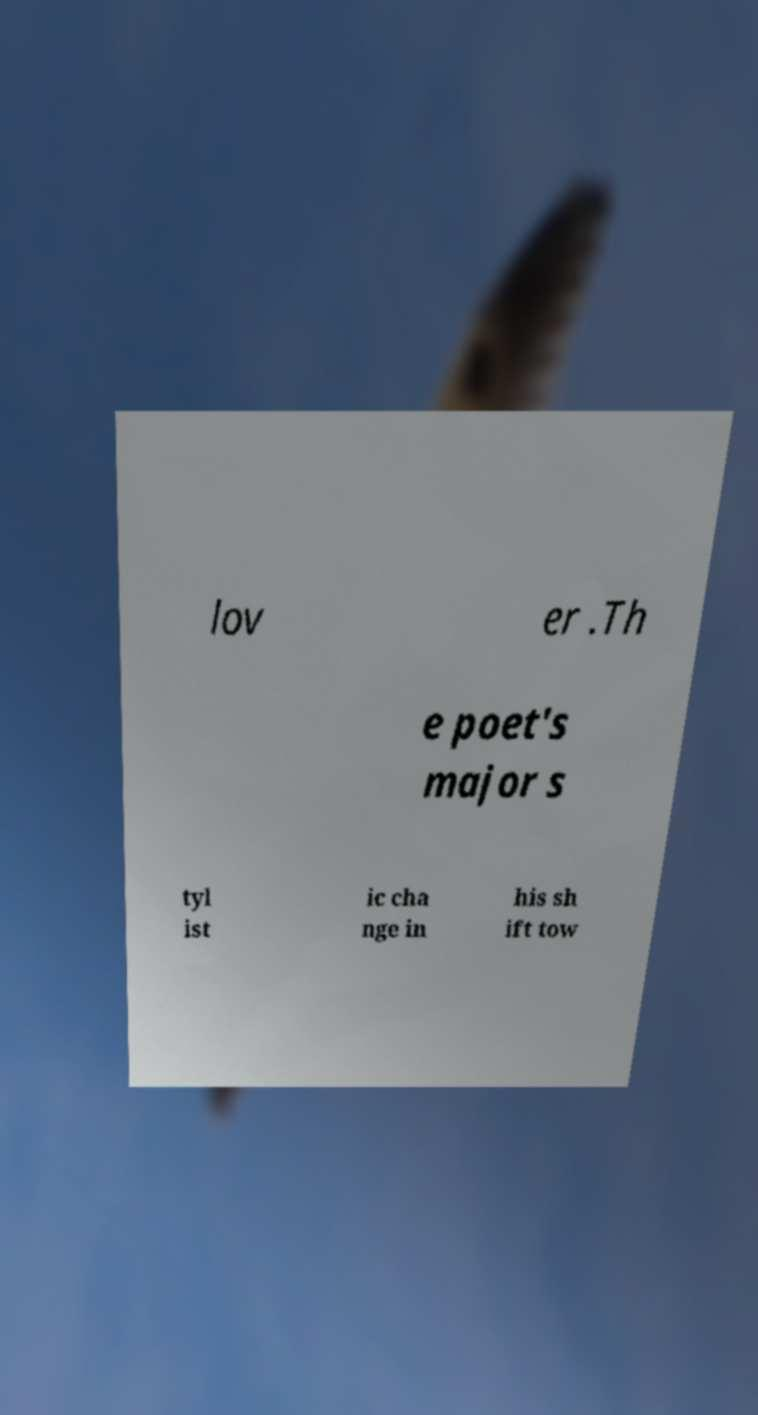For documentation purposes, I need the text within this image transcribed. Could you provide that? lov er .Th e poet's major s tyl ist ic cha nge in his sh ift tow 